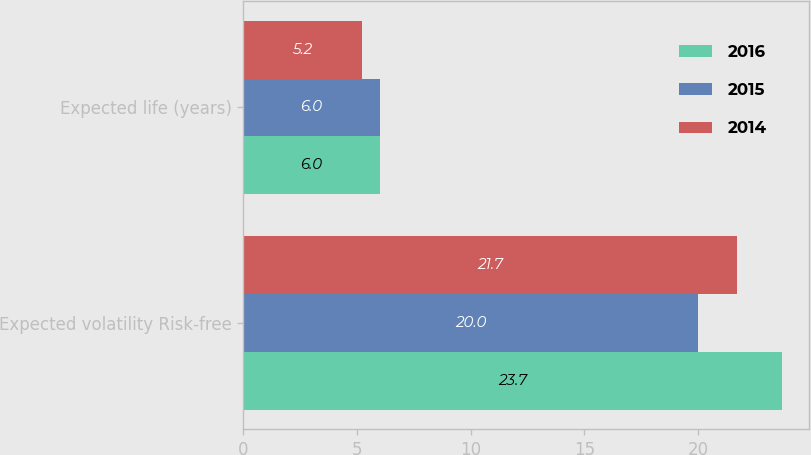Convert chart to OTSL. <chart><loc_0><loc_0><loc_500><loc_500><stacked_bar_chart><ecel><fcel>Expected volatility Risk-free<fcel>Expected life (years)<nl><fcel>2016<fcel>23.7<fcel>6<nl><fcel>2015<fcel>20<fcel>6<nl><fcel>2014<fcel>21.7<fcel>5.2<nl></chart> 